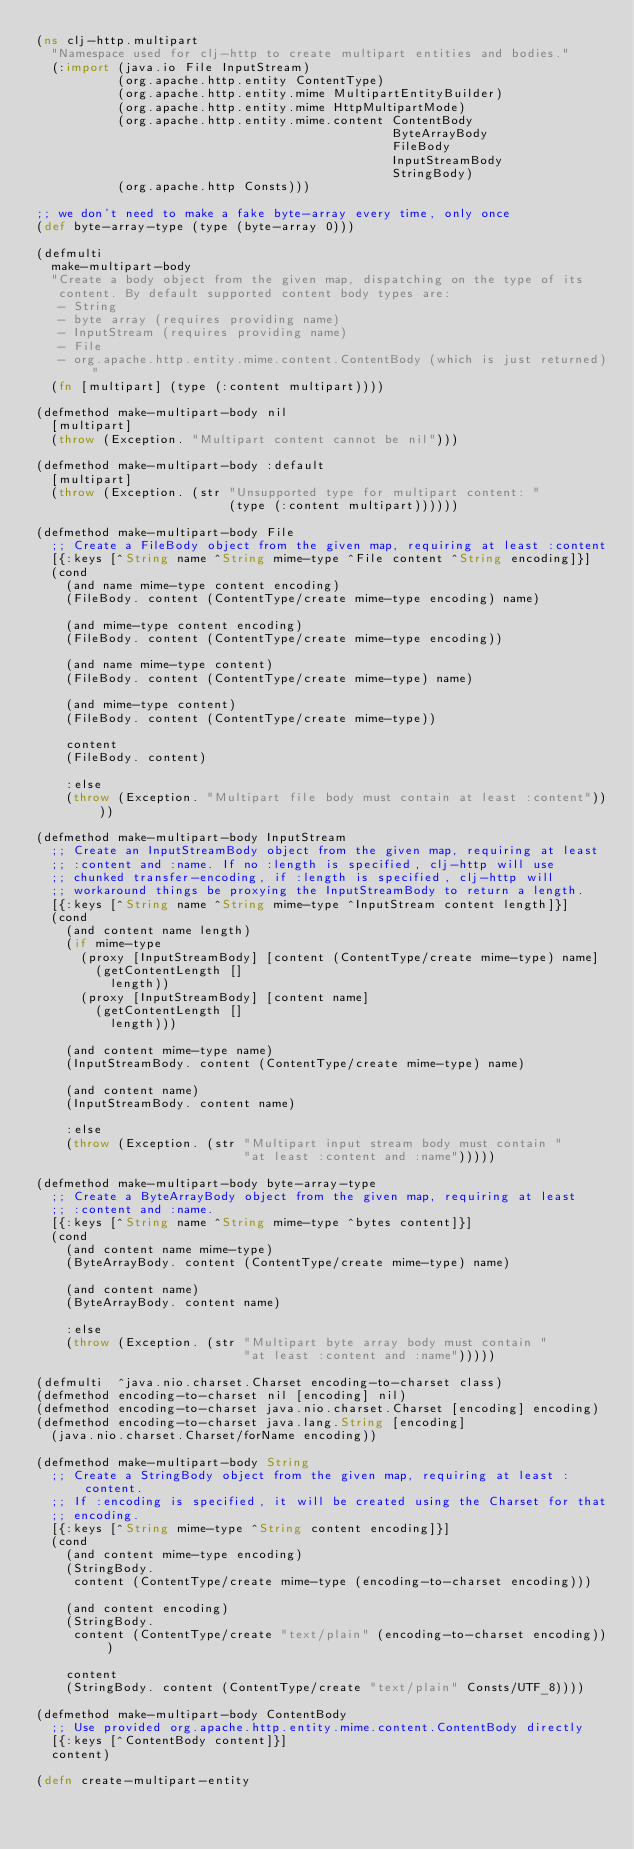<code> <loc_0><loc_0><loc_500><loc_500><_Clojure_>(ns clj-http.multipart
  "Namespace used for clj-http to create multipart entities and bodies."
  (:import (java.io File InputStream)
           (org.apache.http.entity ContentType)
           (org.apache.http.entity.mime MultipartEntityBuilder)
           (org.apache.http.entity.mime HttpMultipartMode)
           (org.apache.http.entity.mime.content ContentBody
                                                ByteArrayBody
                                                FileBody
                                                InputStreamBody
                                                StringBody)
           (org.apache.http Consts)))

;; we don't need to make a fake byte-array every time, only once
(def byte-array-type (type (byte-array 0)))

(defmulti
  make-multipart-body
  "Create a body object from the given map, dispatching on the type of its
   content. By default supported content body types are:
   - String
   - byte array (requires providing name)
   - InputStream (requires providing name)
   - File
   - org.apache.http.entity.mime.content.ContentBody (which is just returned)"
  (fn [multipart] (type (:content multipart))))

(defmethod make-multipart-body nil
  [multipart]
  (throw (Exception. "Multipart content cannot be nil")))

(defmethod make-multipart-body :default
  [multipart]
  (throw (Exception. (str "Unsupported type for multipart content: "
                          (type (:content multipart))))))

(defmethod make-multipart-body File
  ;; Create a FileBody object from the given map, requiring at least :content
  [{:keys [^String name ^String mime-type ^File content ^String encoding]}]
  (cond
    (and name mime-type content encoding)
    (FileBody. content (ContentType/create mime-type encoding) name)

    (and mime-type content encoding)
    (FileBody. content (ContentType/create mime-type encoding))

    (and name mime-type content)
    (FileBody. content (ContentType/create mime-type) name)

    (and mime-type content)
    (FileBody. content (ContentType/create mime-type))

    content
    (FileBody. content)

    :else
    (throw (Exception. "Multipart file body must contain at least :content"))))

(defmethod make-multipart-body InputStream
  ;; Create an InputStreamBody object from the given map, requiring at least
  ;; :content and :name. If no :length is specified, clj-http will use
  ;; chunked transfer-encoding, if :length is specified, clj-http will
  ;; workaround things be proxying the InputStreamBody to return a length.
  [{:keys [^String name ^String mime-type ^InputStream content length]}]
  (cond
    (and content name length)
    (if mime-type
      (proxy [InputStreamBody] [content (ContentType/create mime-type) name]
        (getContentLength []
          length))
      (proxy [InputStreamBody] [content name]
        (getContentLength []
          length)))

    (and content mime-type name)
    (InputStreamBody. content (ContentType/create mime-type) name)

    (and content name)
    (InputStreamBody. content name)

    :else
    (throw (Exception. (str "Multipart input stream body must contain "
                            "at least :content and :name")))))

(defmethod make-multipart-body byte-array-type
  ;; Create a ByteArrayBody object from the given map, requiring at least
  ;; :content and :name.
  [{:keys [^String name ^String mime-type ^bytes content]}]
  (cond
    (and content name mime-type)
    (ByteArrayBody. content (ContentType/create mime-type) name)

    (and content name)
    (ByteArrayBody. content name)

    :else
    (throw (Exception. (str "Multipart byte array body must contain "
                            "at least :content and :name")))))

(defmulti  ^java.nio.charset.Charset encoding-to-charset class)
(defmethod encoding-to-charset nil [encoding] nil)
(defmethod encoding-to-charset java.nio.charset.Charset [encoding] encoding)
(defmethod encoding-to-charset java.lang.String [encoding]
  (java.nio.charset.Charset/forName encoding))

(defmethod make-multipart-body String
  ;; Create a StringBody object from the given map, requiring at least :content.
  ;; If :encoding is specified, it will be created using the Charset for that
  ;; encoding.
  [{:keys [^String mime-type ^String content encoding]}]
  (cond
    (and content mime-type encoding)
    (StringBody.
     content (ContentType/create mime-type (encoding-to-charset encoding)))

    (and content encoding)
    (StringBody.
     content (ContentType/create "text/plain" (encoding-to-charset encoding)))

    content
    (StringBody. content (ContentType/create "text/plain" Consts/UTF_8))))

(defmethod make-multipart-body ContentBody
  ;; Use provided org.apache.http.entity.mime.content.ContentBody directly
  [{:keys [^ContentBody content]}]
  content)

(defn create-multipart-entity</code> 